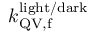Convert formula to latex. <formula><loc_0><loc_0><loc_500><loc_500>k _ { Q V , f } ^ { l i g h t / d a r k }</formula> 